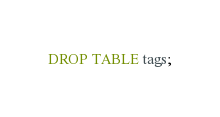<code> <loc_0><loc_0><loc_500><loc_500><_SQL_>DROP TABLE tags;
</code> 